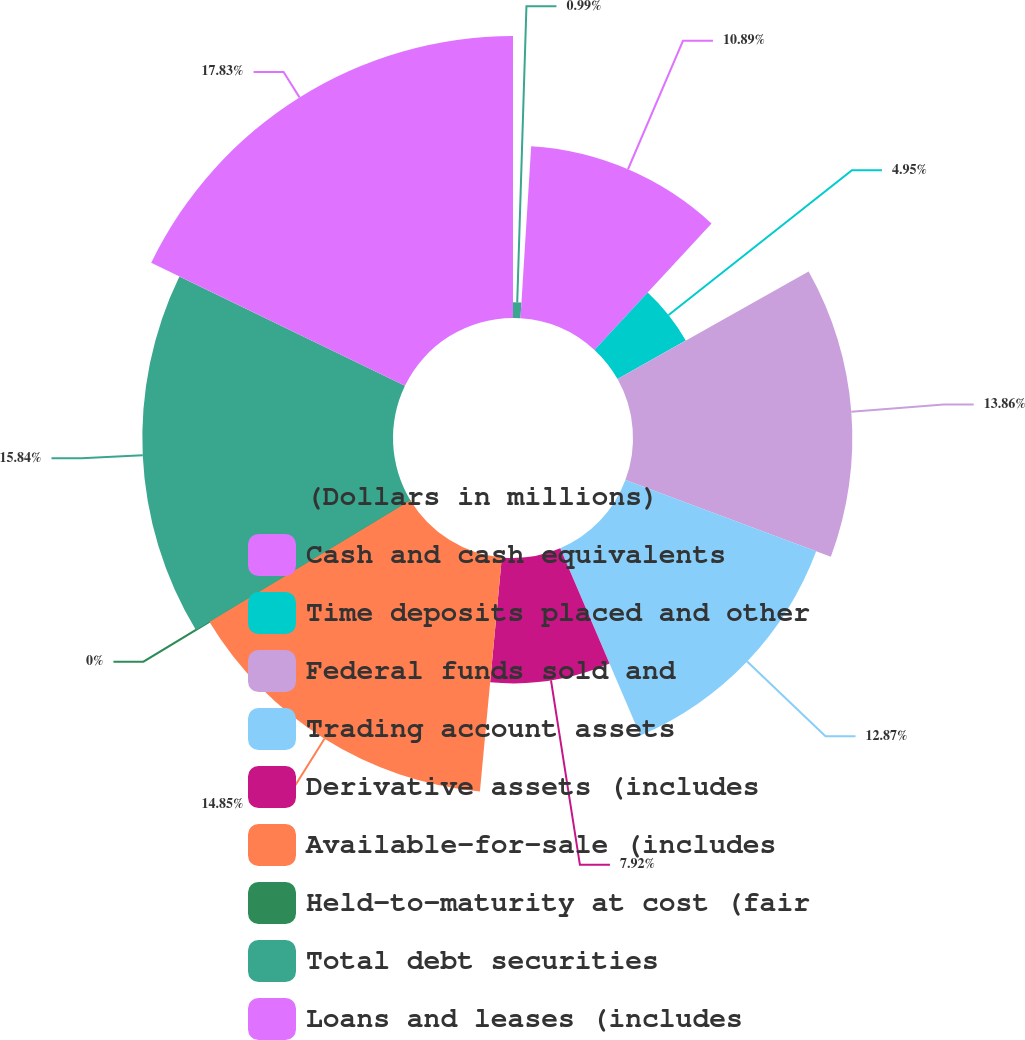<chart> <loc_0><loc_0><loc_500><loc_500><pie_chart><fcel>(Dollars in millions)<fcel>Cash and cash equivalents<fcel>Time deposits placed and other<fcel>Federal funds sold and<fcel>Trading account assets<fcel>Derivative assets (includes<fcel>Available-for-sale (includes<fcel>Held-to-maturity at cost (fair<fcel>Total debt securities<fcel>Loans and leases (includes<nl><fcel>0.99%<fcel>10.89%<fcel>4.95%<fcel>13.86%<fcel>12.87%<fcel>7.92%<fcel>14.85%<fcel>0.0%<fcel>15.84%<fcel>17.82%<nl></chart> 